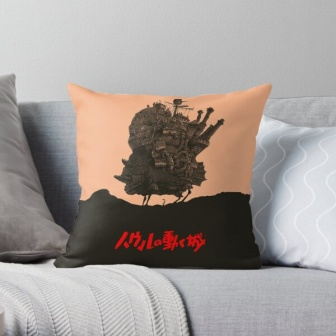Why might someone choose this particular pillow for their living room? Someone might choose this particular pillow for their living room for a few reasons. Firstly, the unique and whimsical castle illustration adds a touch of artistic flair and fantasy, making it a conversation starter and a focal point within the room. Additionally, the reference to 'Miyazaki' could appeal to fans of his films and animations, giving the pillow sentimental or fandom-related value. The color scheme of peach and black is modern and stylish, effortlessly complementing a variety of décor styles. Overall, this pillow could be chosen to reflect a blend of comfort, aesthetic appeal, and personal taste in whimsical and imaginative themes. 